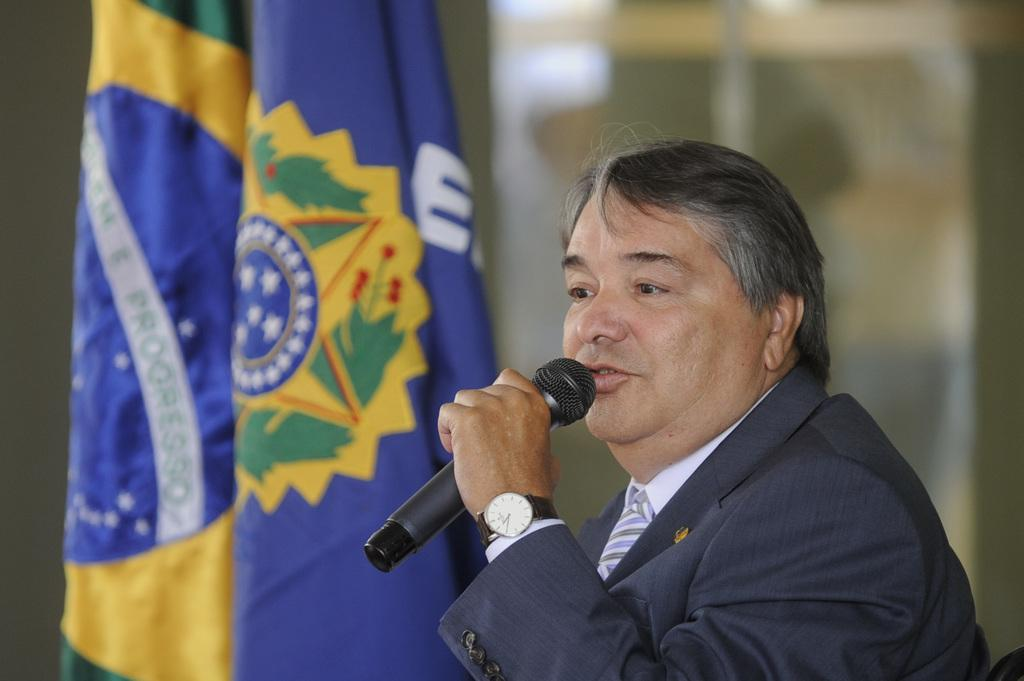What is the person in the image doing? The person is sitting and holding a microphone. What can be seen in the background of the image? There are flags visible in the background of the image. How is the image quality? The image is blurry. What degree does the person in the image have? There is no information about the person's degree in the image. What type of brush is being used by the person in the image? There is no brush visible in the image. 